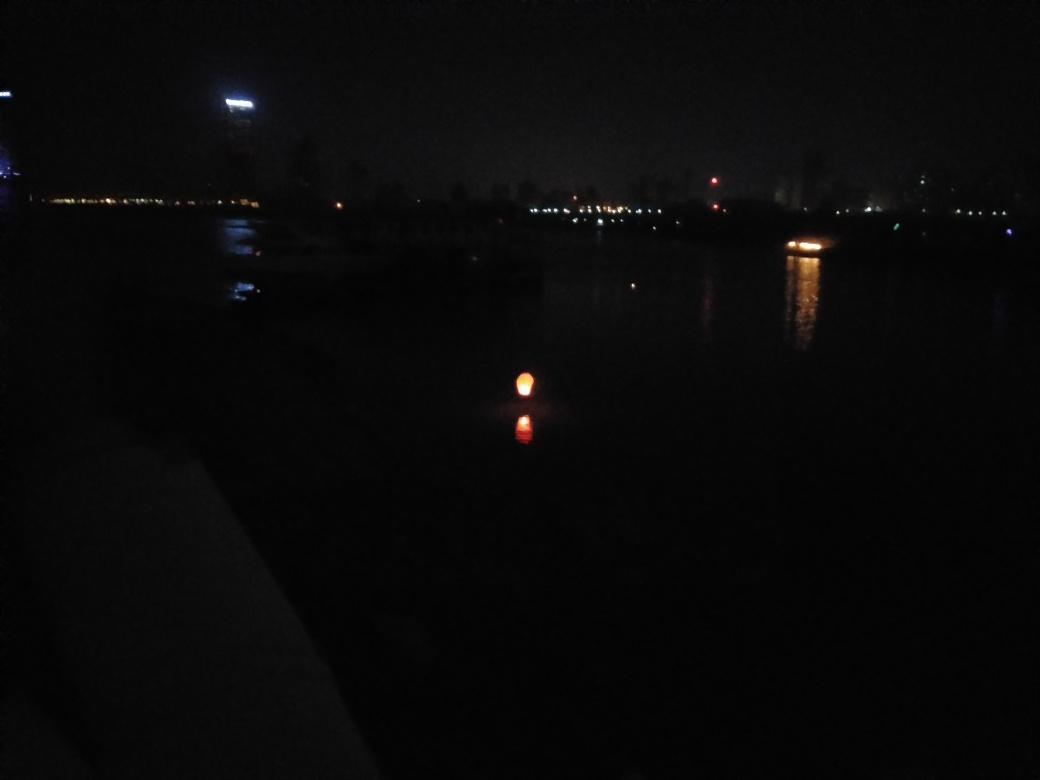What kind of light source is visible in the water? The reflection in the water suggests a single, isolated light source that could be coming from a nearby streetlamp, a boat, or a buoy. Its warm tone indicates it's likely an artificial light. 